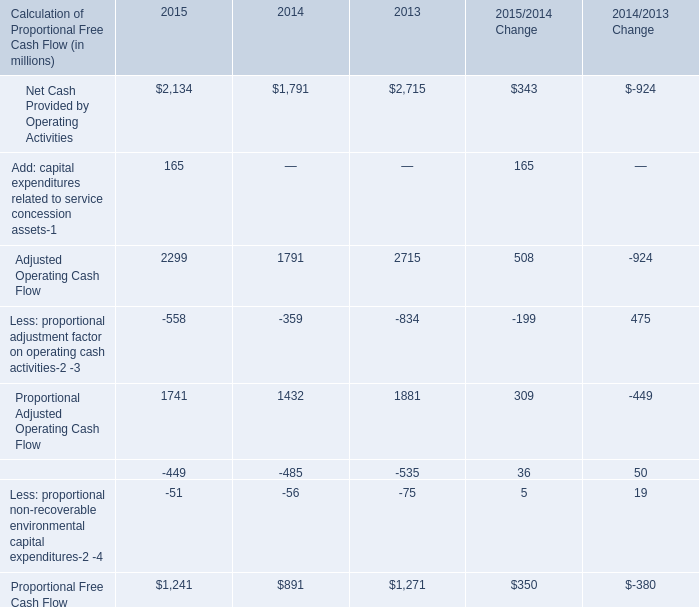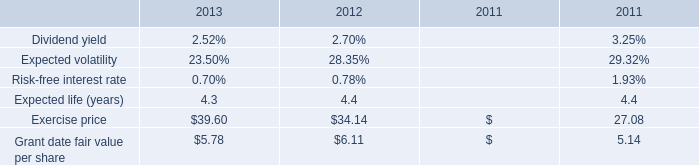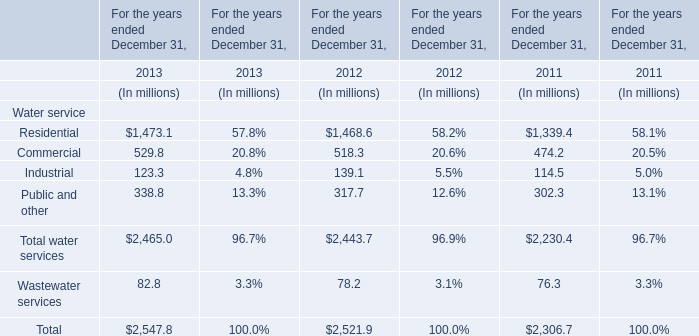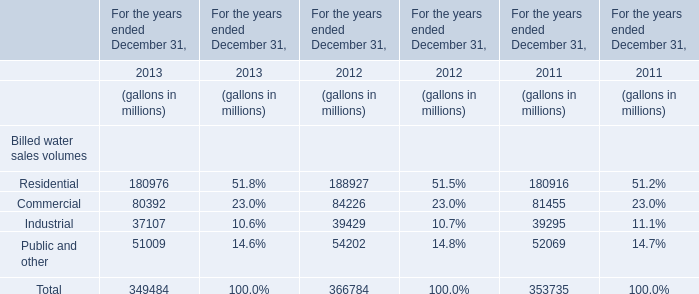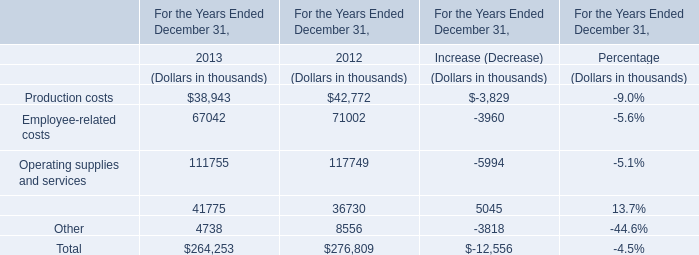In what year is Wastewater services greater than 78.4? 
Answer: 2013. 